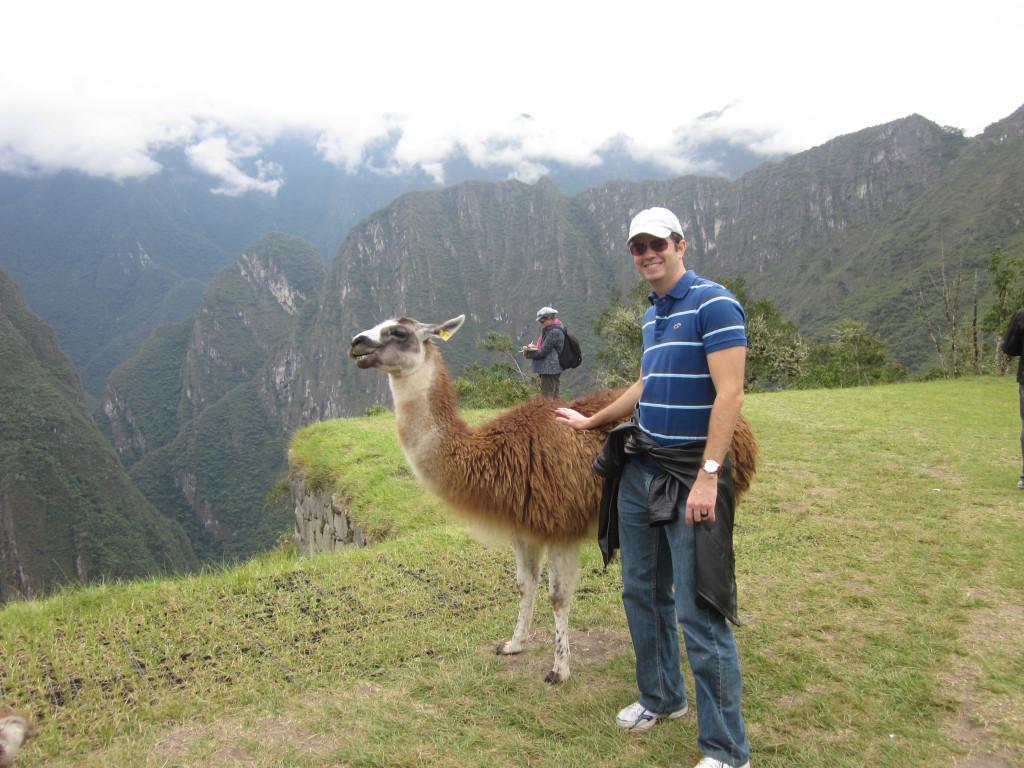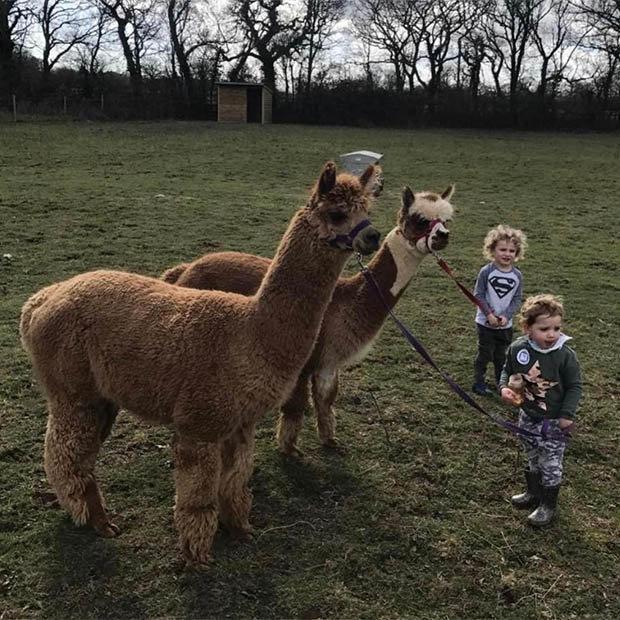The first image is the image on the left, the second image is the image on the right. For the images displayed, is the sentence "The left image includes a leftward-facing brown-and-white llama standing at the edge of a cliff, with mountains in the background." factually correct? Answer yes or no. Yes. 